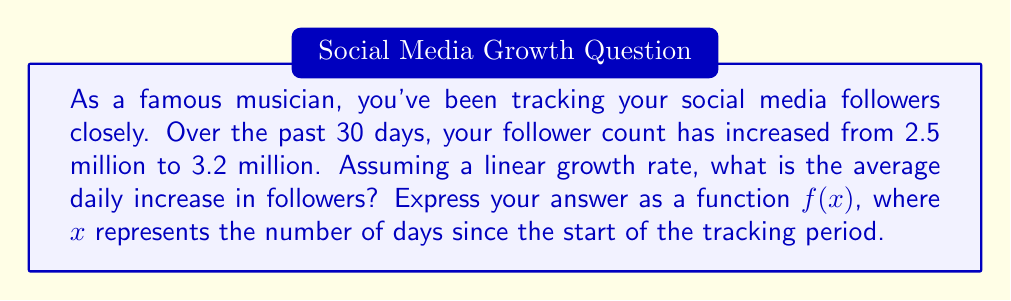Help me with this question. To solve this problem, we need to determine the rate of change in followers over time. Let's break it down step-by-step:

1. Identify the given information:
   - Initial follower count: 2.5 million
   - Final follower count: 3.2 million
   - Time period: 30 days

2. Calculate the total increase in followers:
   $3.2 \text{ million} - 2.5 \text{ million} = 0.7 \text{ million}$

3. Calculate the average daily increase:
   $$\text{Average daily increase} = \frac{\text{Total increase}}{\text{Number of days}}$$
   $$\text{Average daily increase} = \frac{0.7 \text{ million}}{30 \text{ days}} = \frac{700,000}{30} = 23,333.33 \text{ followers per day}$$

4. Express the follower count as a function of time:
   Let $f(x)$ be the number of followers after $x$ days.
   The function will have the form: $f(x) = mx + b$, where:
   $m$ is the daily increase (slope)
   $b$ is the initial follower count (y-intercept)

   Therefore, $f(x) = 23,333.33x + 2,500,000$

This function represents the linear growth of followers over time, where $x$ is the number of days since the start of the tracking period.
Answer: $f(x) = 23,333.33x + 2,500,000$, where $x$ is the number of days since the start of the tracking period. 